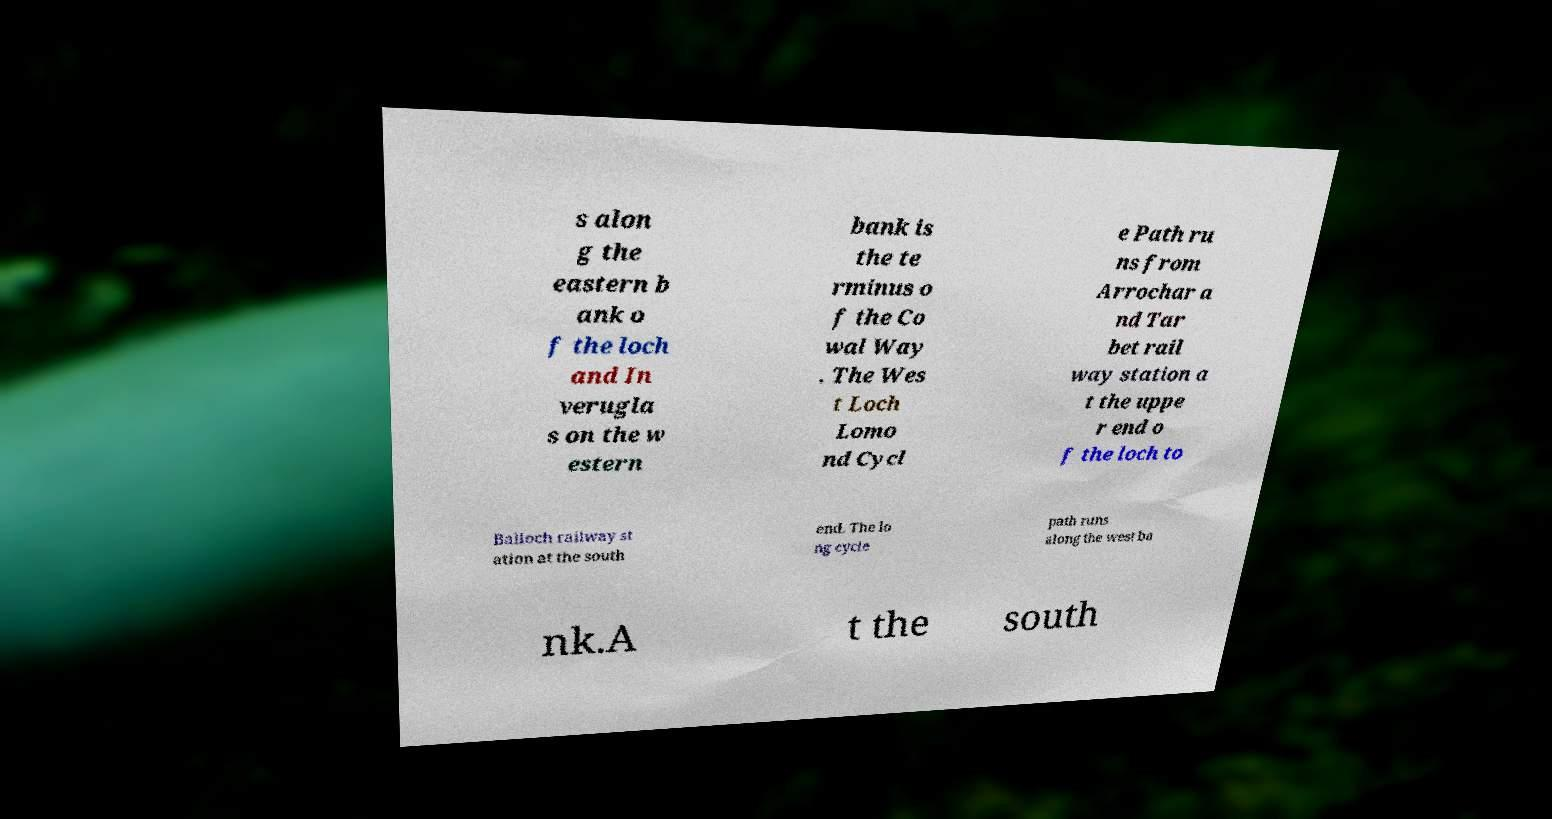I need the written content from this picture converted into text. Can you do that? s alon g the eastern b ank o f the loch and In verugla s on the w estern bank is the te rminus o f the Co wal Way . The Wes t Loch Lomo nd Cycl e Path ru ns from Arrochar a nd Tar bet rail way station a t the uppe r end o f the loch to Balloch railway st ation at the south end. The lo ng cycle path runs along the west ba nk.A t the south 